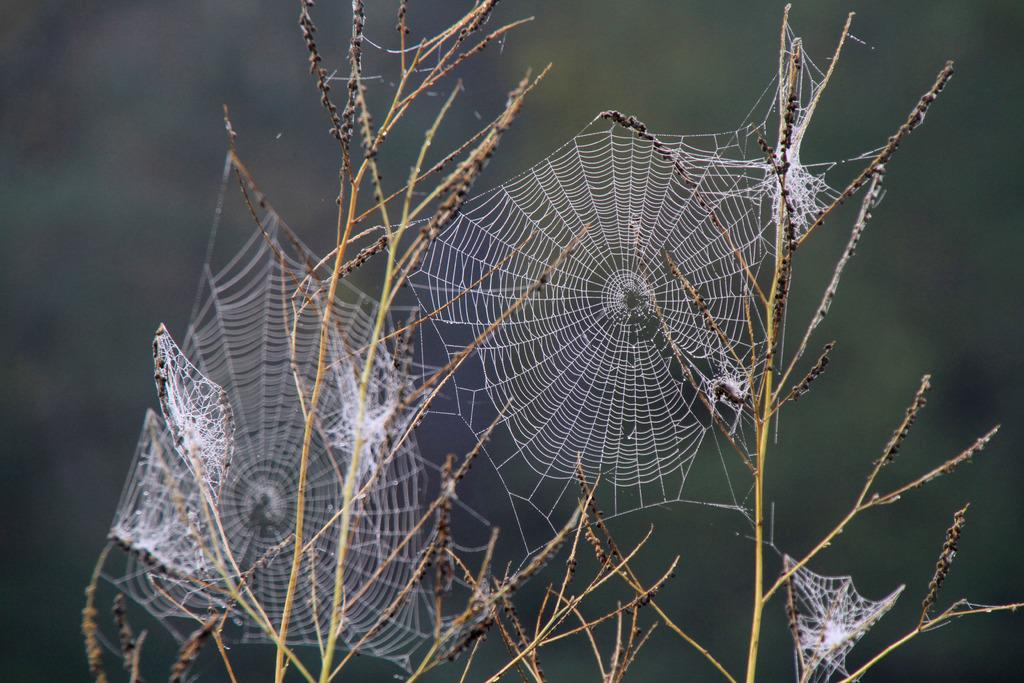What can be seen on the plants in the image? There are spider nets on the plants in the image. Can you identify any animals in the image? Yes, there is a spider in the image. What is the color of the background in the image? The background of the image is dark. When might this image have been taken? The image may have been taken during the night, given the dark background. What type of shoes can be seen in the image? There are no shoes present in the image. How does the spider breathe in the image? The image does not show the spider breathing, and it is not possible to determine this information from the image. 